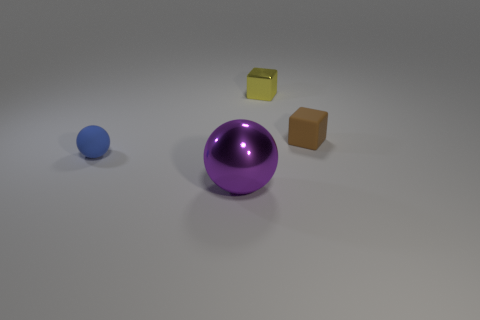What number of cylinders are tiny blue rubber objects or yellow things?
Provide a short and direct response. 0. What is the color of the sphere that is made of the same material as the yellow thing?
Ensure brevity in your answer.  Purple. There is a metallic thing behind the purple shiny ball; is its size the same as the blue sphere?
Ensure brevity in your answer.  Yes. Are the small brown cube and the ball on the right side of the small blue ball made of the same material?
Offer a very short reply. No. There is a small rubber thing left of the tiny brown thing; what color is it?
Your answer should be very brief. Blue. Are there any matte objects behind the shiny thing in front of the small blue matte sphere?
Provide a short and direct response. Yes. Do the small rubber thing that is left of the small brown matte block and the tiny matte object right of the purple metallic sphere have the same color?
Give a very brief answer. No. What number of purple shiny things are right of the blue matte sphere?
Keep it short and to the point. 1. What number of big metal spheres have the same color as the big thing?
Offer a very short reply. 0. Are the sphere that is to the left of the big purple sphere and the large thing made of the same material?
Keep it short and to the point. No. 